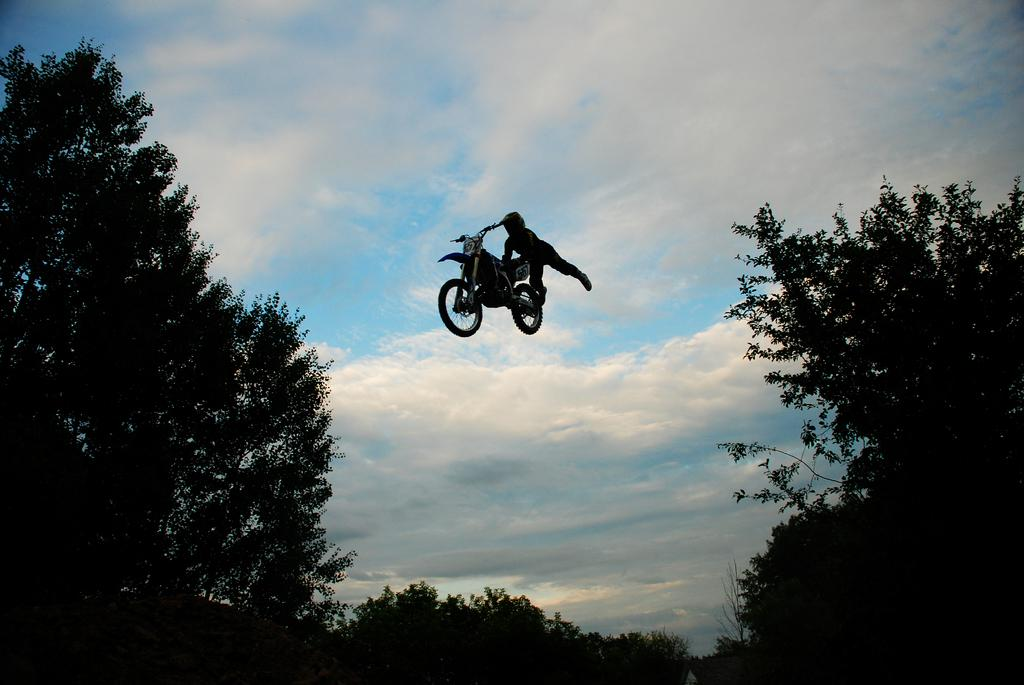What is the person in the image doing? The person is in the air, holding a bike. What can be seen in the background of the image? Trees and the sky are visible in the image. What is the condition of the sky in the image? The sky is visible, and clouds are present in it. What type of offer is the person making with their finger in the image? There is no person making an offer with their finger in the image; the person is holding a bike. What day of the week is depicted in the image? The image does not depict a specific day of the week. 